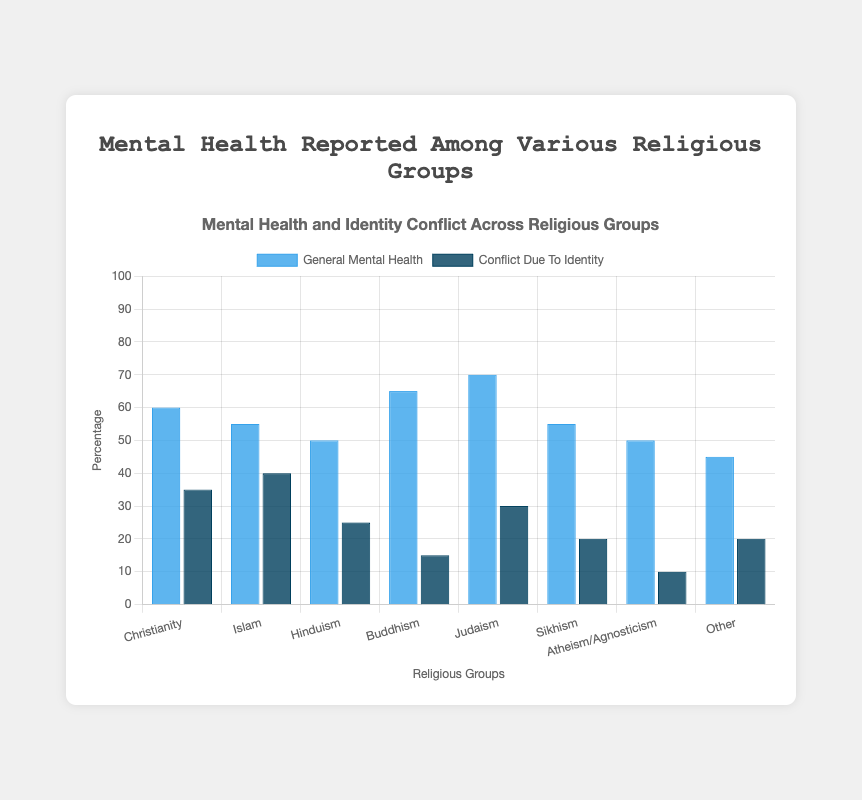How many more people report conflict due to identity in Islam than in Hinduism? The chart shows that 40% of people in Islam report conflict due to identity, whereas 25% of people in Hinduism report the same. The difference is 40% - 25% = 15%
Answer: 15% Which religious group has the highest general mental health reported? The chart shows that Judaism has the highest percentage of general mental health reported at 70%.
Answer: Judaism Which religious groups have the same percentage of general mental health reported? Both Islam and Sikhism show the same percentage for general mental health reported at 55%.
Answer: Islam and Sikhism What is the average general mental health reported among all religious groups represented? Sum the general mental health percentages: 60 + 55 + 50 + 65 + 70 + 55 + 50 + 45 = 450. Divide by the number of groups: 450 / 8 = 56.25%
Answer: 56.25% Which religious group reports the least conflict due to identity? The chart shows that Atheism/Agnosticism has the least conflict due to identity reported at 10%.
Answer: Atheism/Agnosticism How much more is the general mental health in Buddhism compared to Atheism/Agnosticism? Buddhism has a general mental health percentage of 65%, and Atheism/Agnosticism has 50%. The difference is 65% - 50% = 15%.
Answer: 15% Among the given groups, if we combine Christianity and Islam, how much total conflict due to identity would be? Adding conflict due to identity for Christianity (35%) and Islam (40%), we get 35% + 40% = 75%.
Answer: 75% Comparing Christianity and Judaism, which reports higher levels of conflict due to identity, and by how much? Christianity reports 35% conflict due to identity, and Judaism reports 30%. The difference is 35% - 30% = 5%.
Answer: Christianity, by 5% 